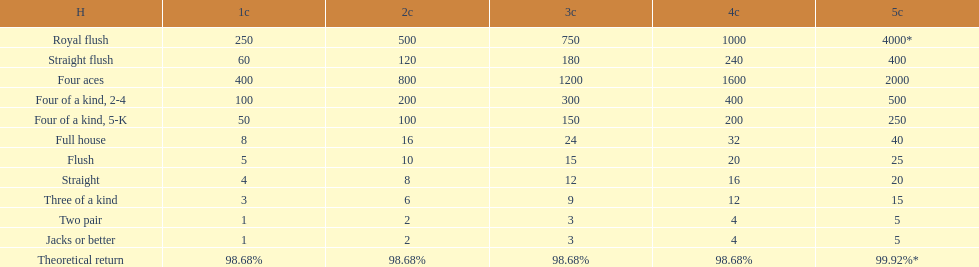The number of flush wins at one credit to equal one flush win at 5 credits. 5. 